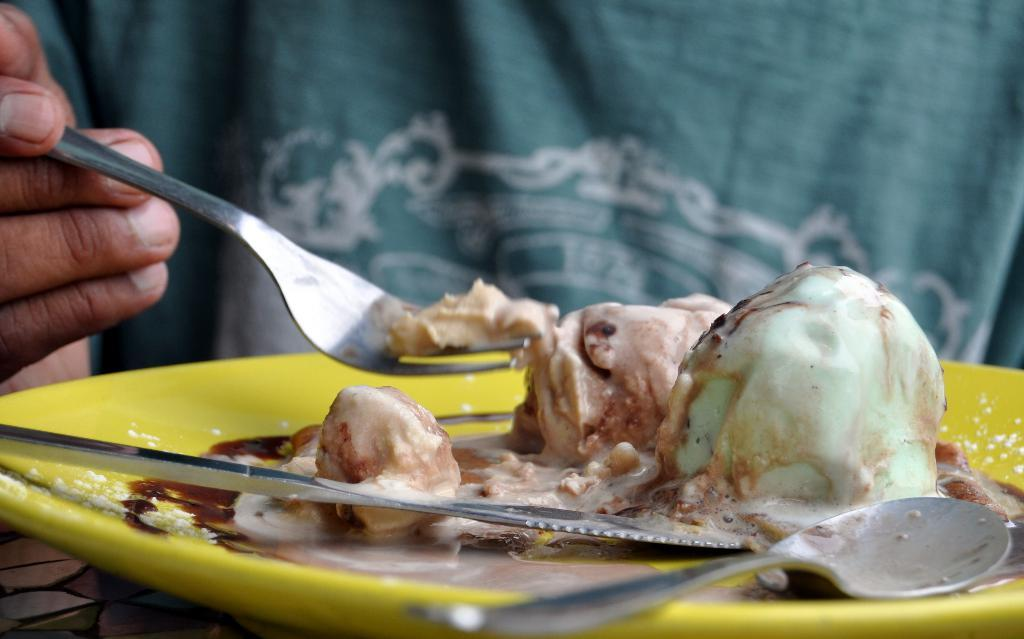What color is the plate in the image? The plate in the image is yellow. What is on the plate? The plate has ice creams on it. How many spoons are on the plate? There are 2 spoons on the plate. Can you describe the person in the background of the image? The person in the background is holding a fork. What is on the fork? There is some cream on the fork. Is the person in the image wearing a mask to protect against a disease? There is no mention of a mask or any disease in the provided facts. The image only shows a yellow plate with ice creams, spoons, and a person in the background holding a fork with some cream on it. 